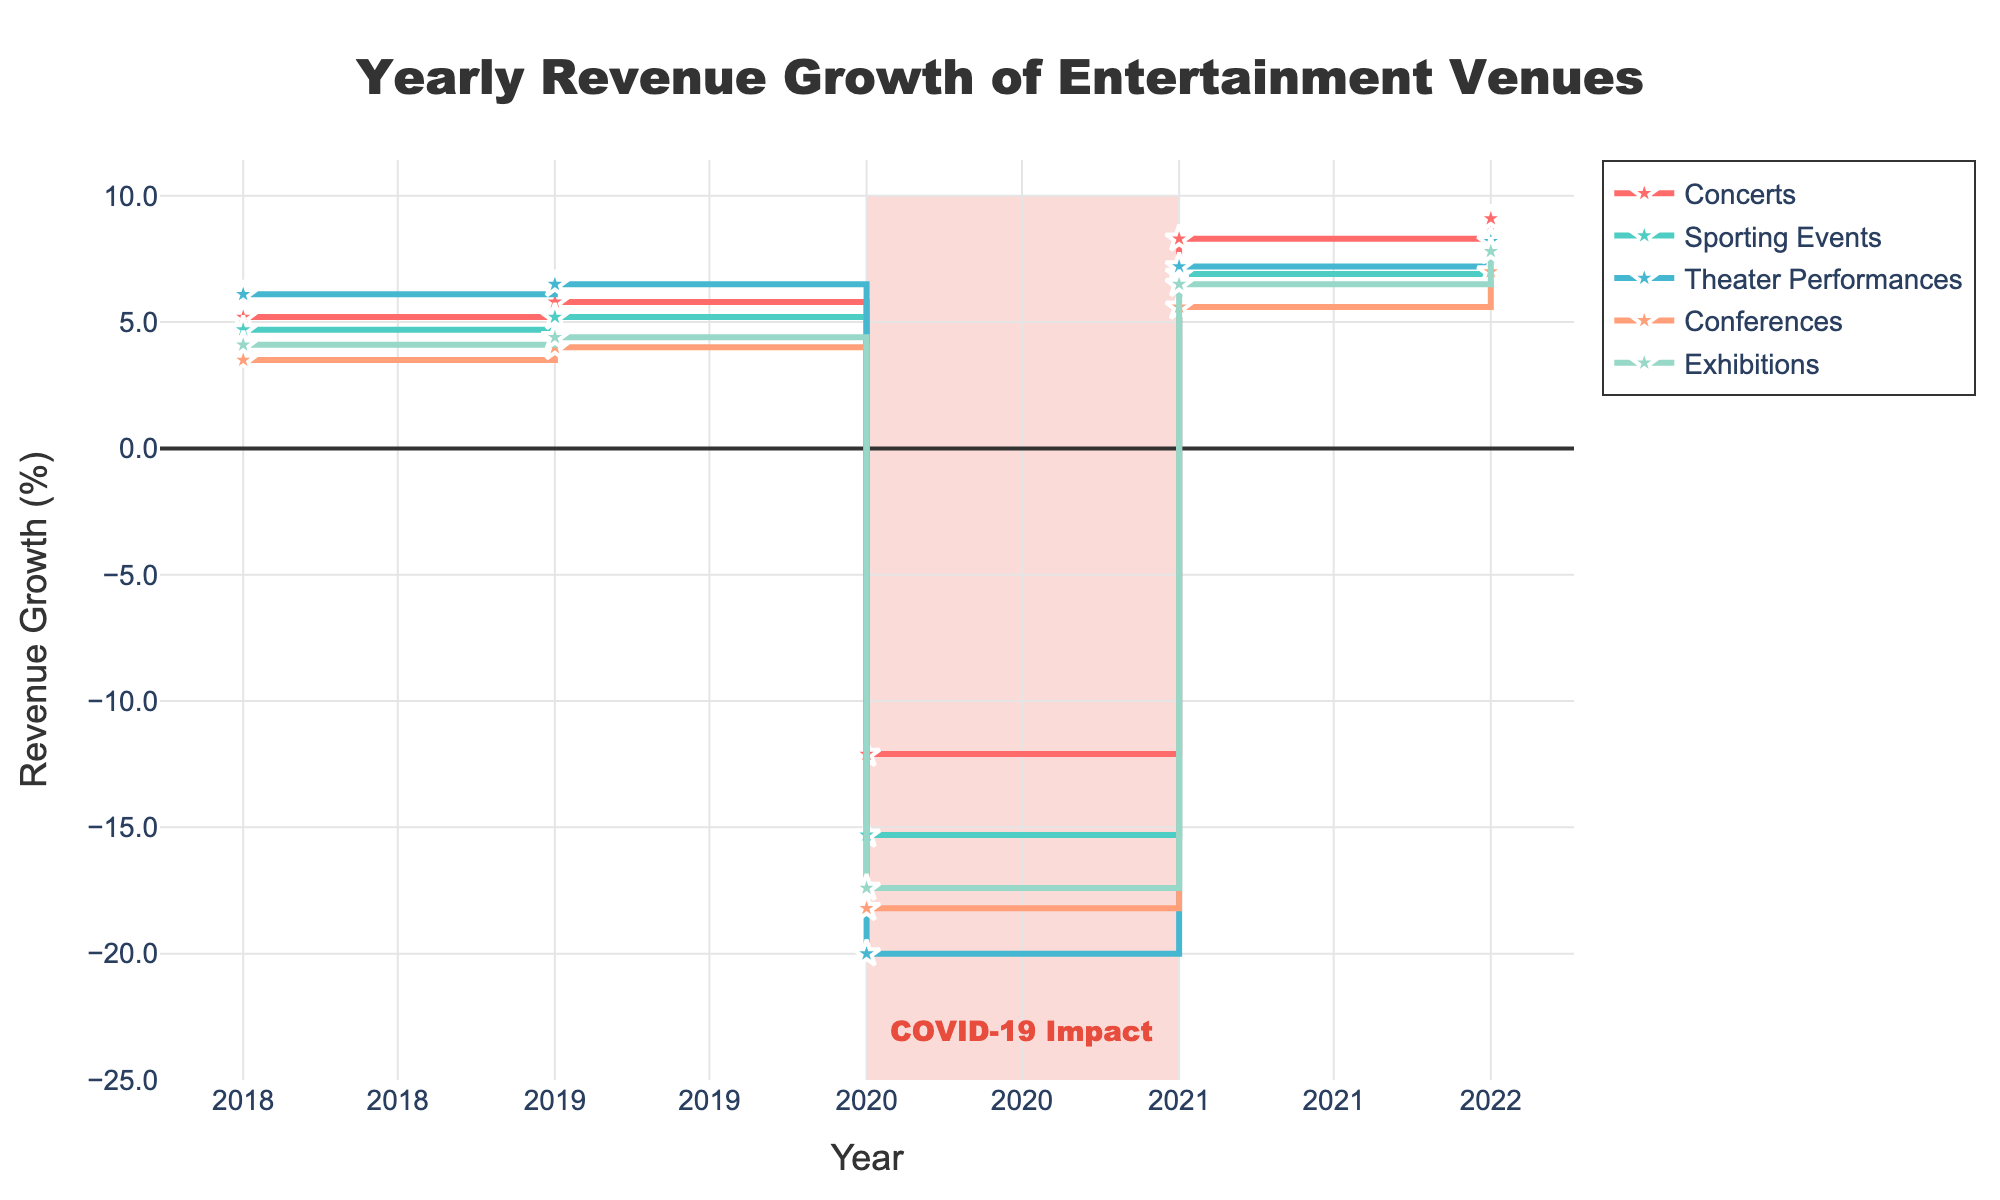What is the title of the figure? The title is typically located at the top center of the figure, stating the main subject of the data being presented. In this case, the title reads "Yearly Revenue Growth of Entertainment Venues."
Answer: Yearly Revenue Growth of Entertainment Venues How many types of events are shown in the figure? The legend of the figure lists the distinct types of events being analyzed for yearly revenue growth. There are five event types listed.
Answer: 5 Which event type saw the highest revenue growth in 2022? By examining the data points for the year 2022, we see that "Concerts" at Madison Square Garden had the highest revenue growth.
Answer: Concerts What was the revenue growth percentage for Theater Performances in 2019? Check the location of the data point for Theater Performances in 2019, indicated by Broadway Theatres in the corresponding legend entry. The revenue growth percentage shown next to the data point is 6.5%.
Answer: 6.5% Which two event types experienced the largest drop in revenue growth in 2020? Look at the data points for 2020, focusing on the values on the y-axis. The "Theater Performances" and "Conferences" experienced the largest drops, with -20.0% and -18.2%, respectively.
Answer: Theater Performances and Conferences What was the approximate average revenue growth for Sporting Events from 2018 to 2022? Identify the revenue growth values for Sporting Events across all years. Add them up and divide by the number of years (5). For Sporting Events: (4.7 + 5.2 - 15.3 + 6.9 + 7.5) / 5 = 1.8%.
Answer: 1.8% During which year did Conferences see a revenue growth greater than 5% after the decline in 2020? Identify the revenue growth for Conferences from 2021 onwards. The year 2021 shows revenue growth at 5.6%.
Answer: 2021 How did the revenue growth of Exhibitions compare between 2019 and 2021? Look at the data points for Exhibitions in these two years and compare them directly. Revenue growth was 4.4% in 2019 and 6.5% in 2021, showing an increase.
Answer: Increased What annotation highlights a significant period on the plot? Check for any text or shapes on the plot marking significant events or periods. The annotation is "COVID-19 Impact," highlighting the impact period around 2020.
Answer: COVID-19 Impact What is the general trend for revenue growth across all event types from 2021 to 2022? Examine the slope of the lines for all event types between 2021 and 2022. All the lines have an upward trend, indicating an overall increase in revenue growth.
Answer: Increase 